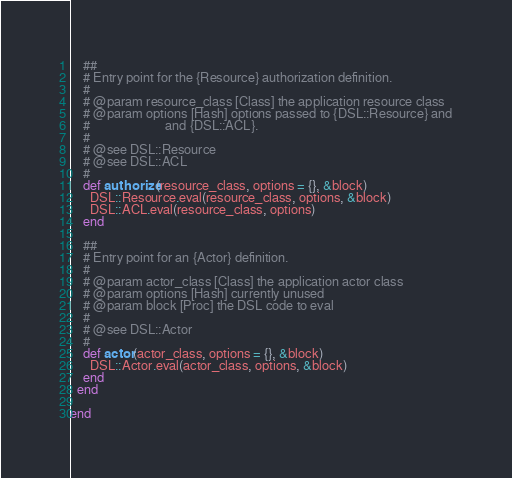<code> <loc_0><loc_0><loc_500><loc_500><_Ruby_>
    ##
    # Entry point for the {Resource} authorization definition.
    #
    # @param resource_class [Class] the application resource class
    # @param options [Hash] options passed to {DSL::Resource} and
    #                       and {DSL::ACL}.
    #
    # @see DSL::Resource
    # @see DSL::ACL
    #
    def authorize(resource_class, options = {}, &block)
      DSL::Resource.eval(resource_class, options, &block)
      DSL::ACL.eval(resource_class, options)
    end

    ##
    # Entry point for an {Actor} definition.
    #
    # @param actor_class [Class] the application actor class
    # @param options [Hash] currently unused
    # @param block [Proc] the DSL code to eval
    #
    # @see DSL::Actor
    #
    def actor(actor_class, options = {}, &block)
      DSL::Actor.eval(actor_class, options, &block)
    end
  end

end
</code> 